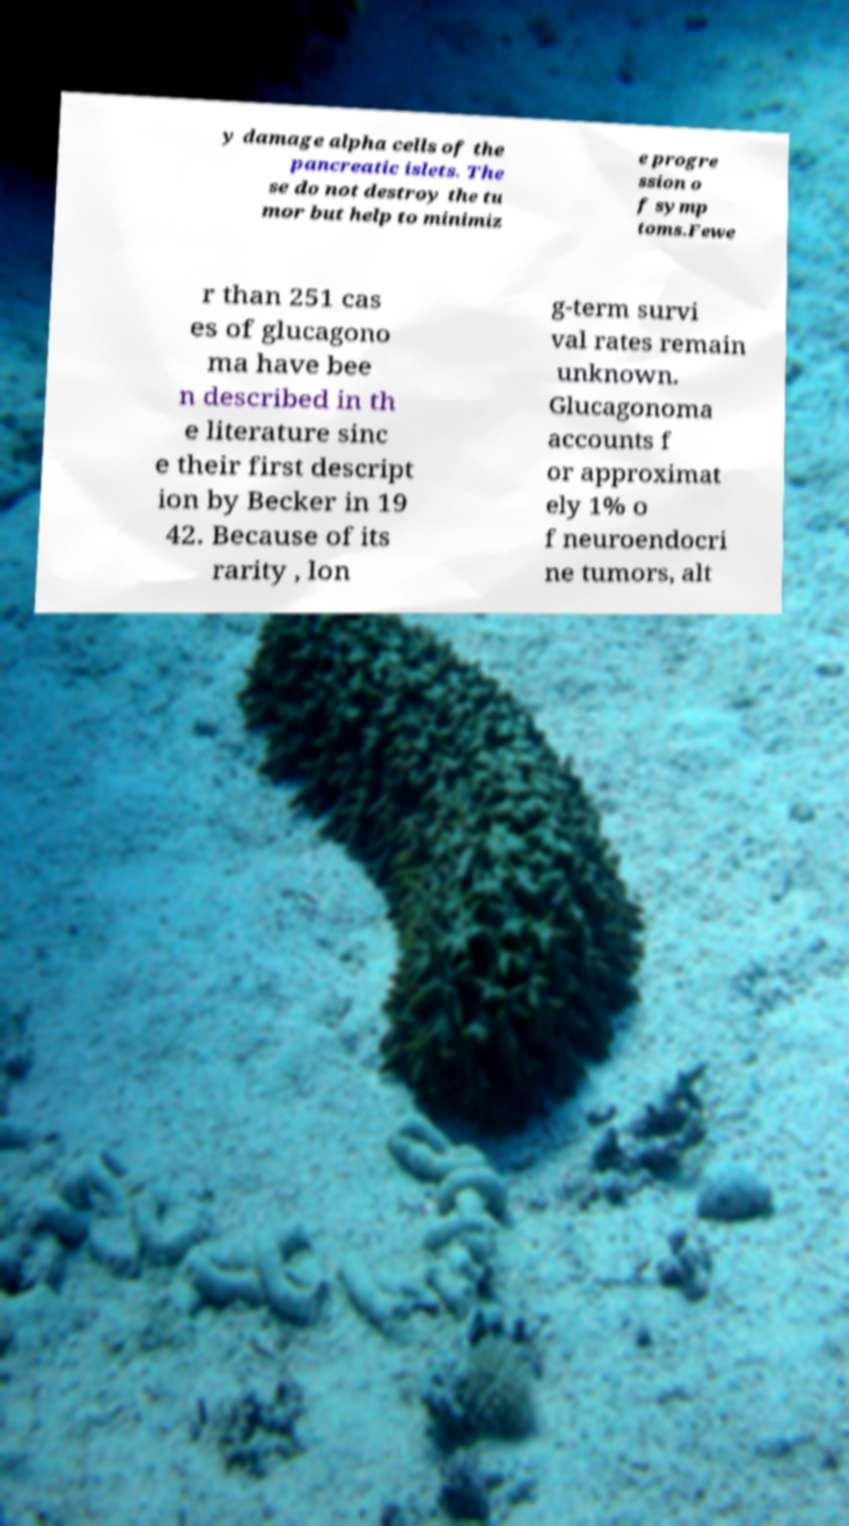There's text embedded in this image that I need extracted. Can you transcribe it verbatim? y damage alpha cells of the pancreatic islets. The se do not destroy the tu mor but help to minimiz e progre ssion o f symp toms.Fewe r than 251 cas es of glucagono ma have bee n described in th e literature sinc e their first descript ion by Becker in 19 42. Because of its rarity , lon g-term survi val rates remain unknown. Glucagonoma accounts f or approximat ely 1% o f neuroendocri ne tumors, alt 